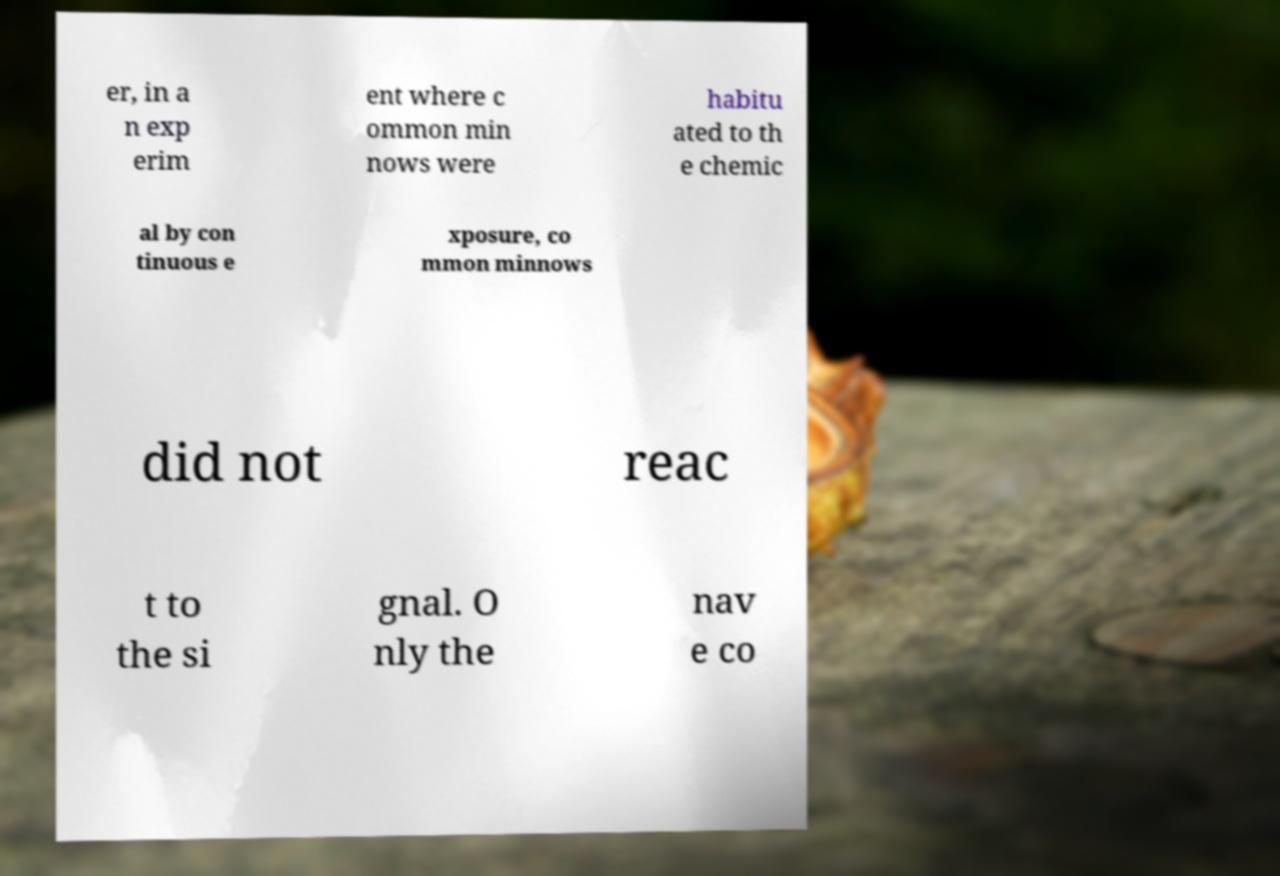What messages or text are displayed in this image? I need them in a readable, typed format. er, in a n exp erim ent where c ommon min nows were habitu ated to th e chemic al by con tinuous e xposure, co mmon minnows did not reac t to the si gnal. O nly the nav e co 